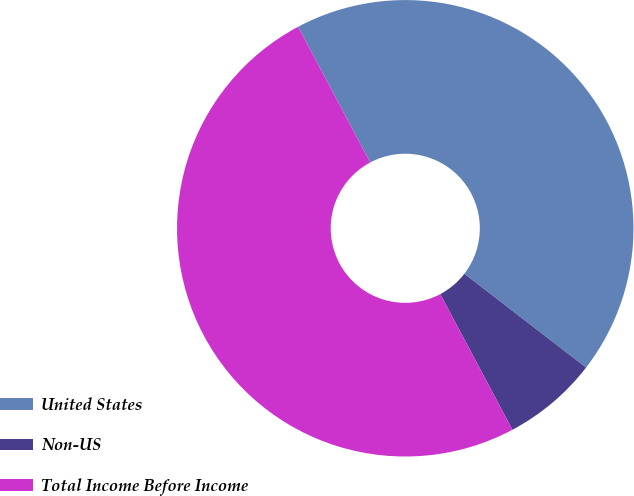Convert chart to OTSL. <chart><loc_0><loc_0><loc_500><loc_500><pie_chart><fcel>United States<fcel>Non-US<fcel>Total Income Before Income<nl><fcel>43.23%<fcel>6.77%<fcel>50.0%<nl></chart> 